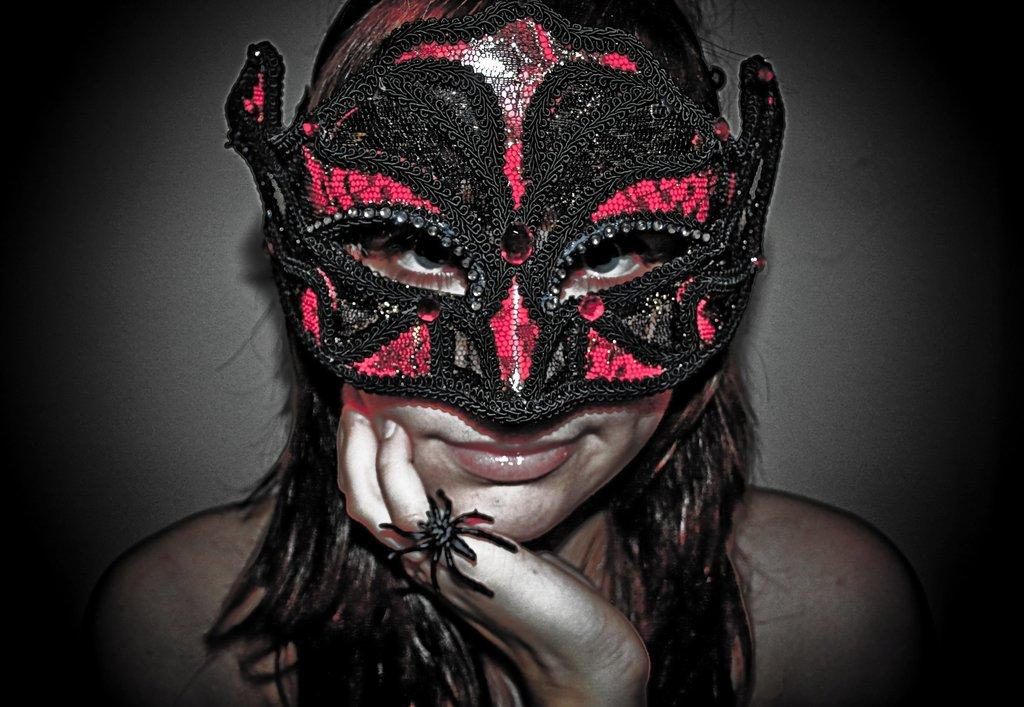Who is the main subject in the image? There is a lady in the center of the image. What is the lady wearing on her face? The lady is wearing a mask. What type of jewelry is the lady wearing? The lady is wearing a ring. What can be seen in the background of the image? There is a wall visible in the background of the image. How many letters are being delivered by the ladybug in the image? There is no ladybug present in the image, so it is not possible to determine how many letters are being delivered. 